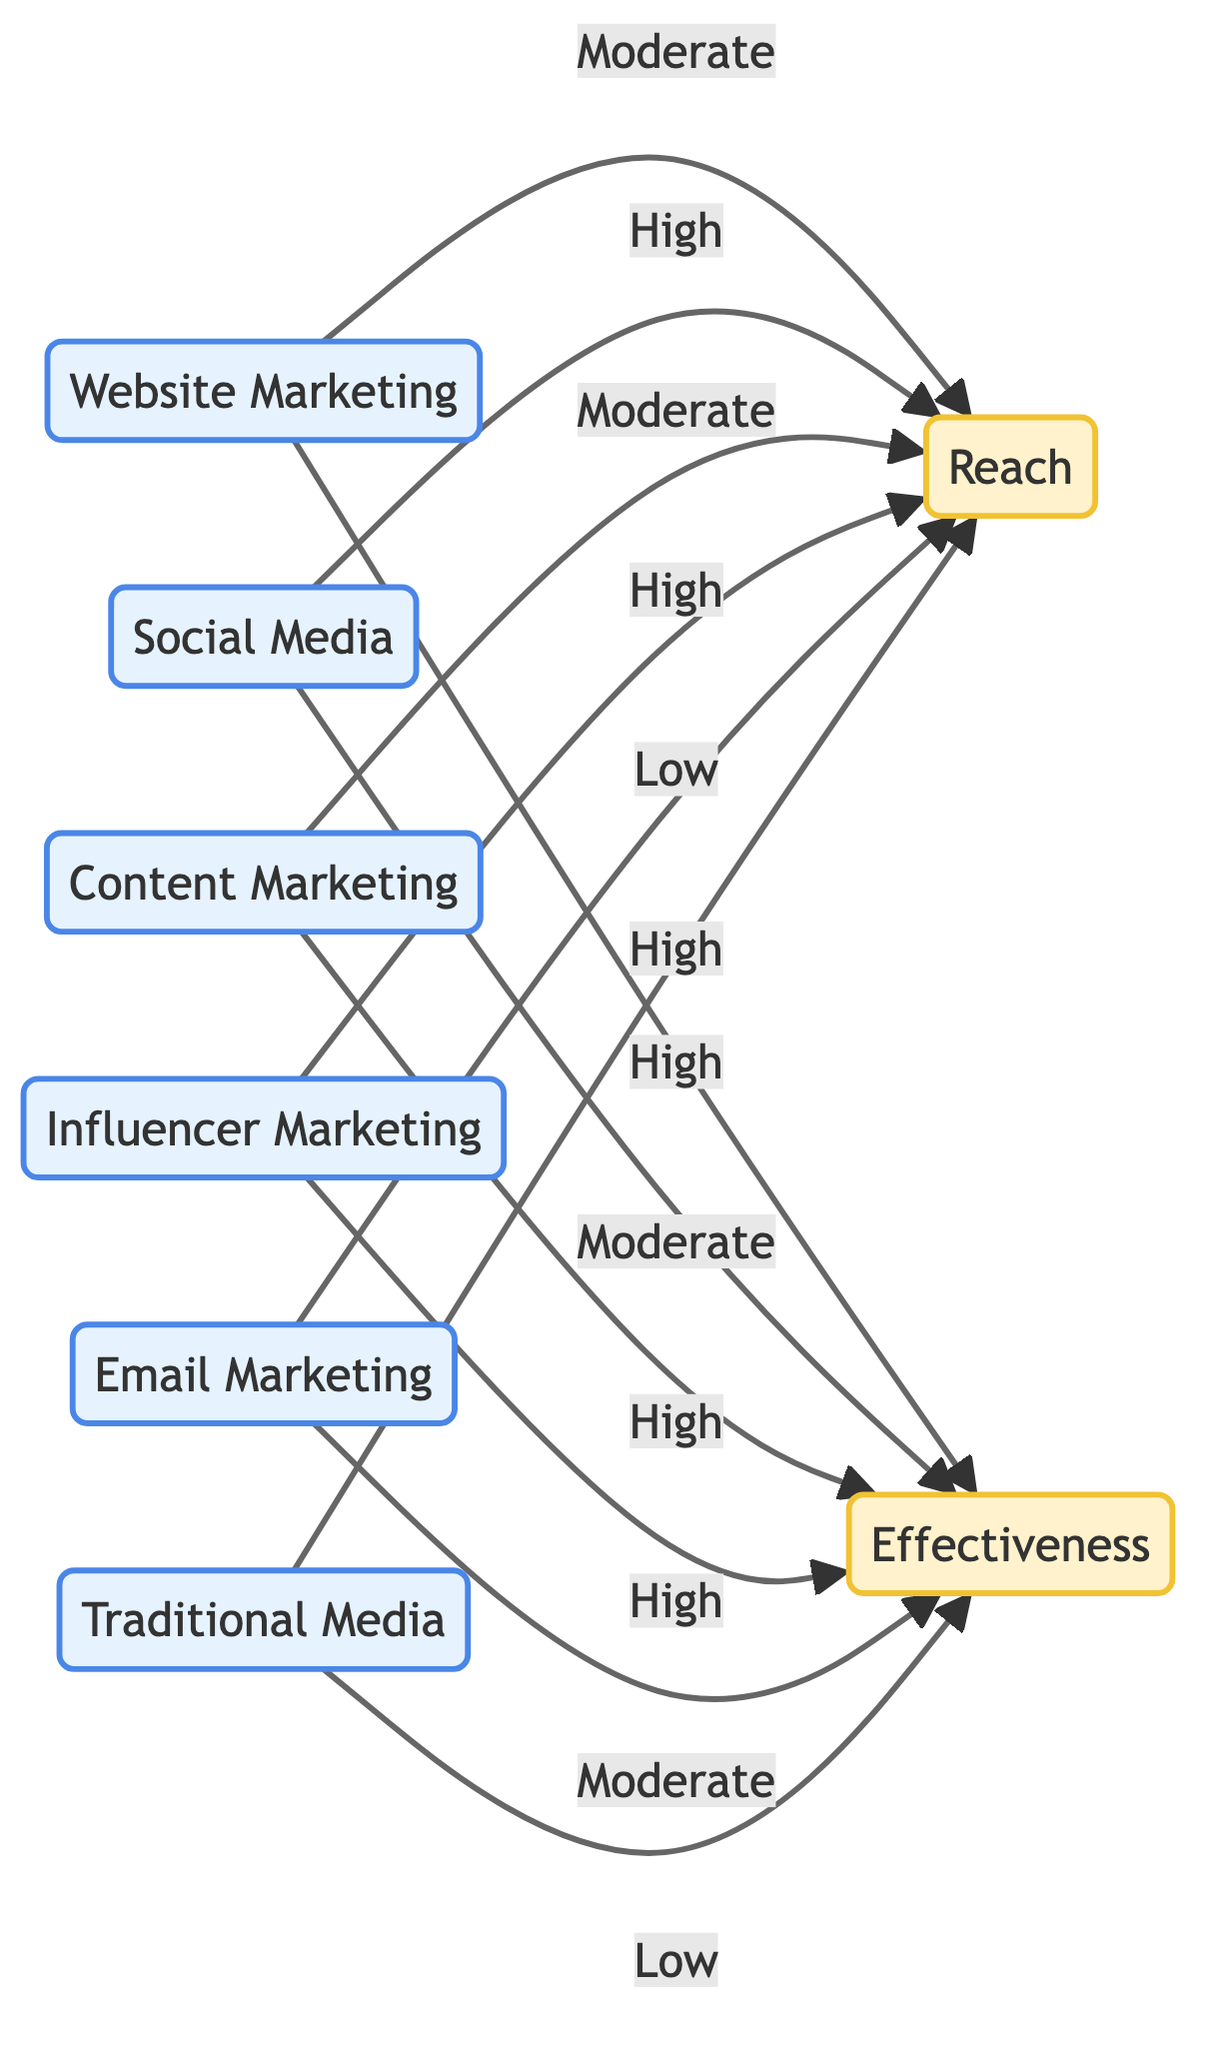What is the effectiveness of website marketing? The diagram shows that the effectiveness of website marketing is represented as "High."
Answer: High What is the reach of email marketing? According to the diagram, email marketing has a reach value labeled as "Low."
Answer: Low Which marketing channel has the highest effectiveness? By examining the diagram, influencer marketing is the only channel that has both high reach and high effectiveness, indicating it’s the top performer.
Answer: Influencer Marketing How many marketing channels are represented in the diagram? The diagram lists a total of 6 distinct marketing channels: website marketing, social media, content marketing, influencer marketing, email marketing, and traditional media, totaling six.
Answer: 6 What is the reach of traditional media? The diagram indicates that traditional media has a reach level of "High."
Answer: High Which marketing channel has moderate effectiveness? A closer look at the effectiveness levels reveals that social media and email marketing are the two channels that have a "Moderate" effectiveness.
Answer: Social Media and Email Marketing Is there any marketing channel with low reach? Reviewing the diagram shows that email marketing is the only channel with the label "Low" for reach, which confirms that it lacks broad reach compared to others.
Answer: Email Marketing What is the relationship between influencer marketing and effectiveness? The diagram illustrates that influencer marketing has both "High" reach and "High" effectiveness, indicating a strong positive relationship in both dimensions.
Answer: High Which marketing channel shows moderate reach? Upon examination, content marketing is the channel that displays a "Moderate" reach value according to the diagram.
Answer: Content Marketing 